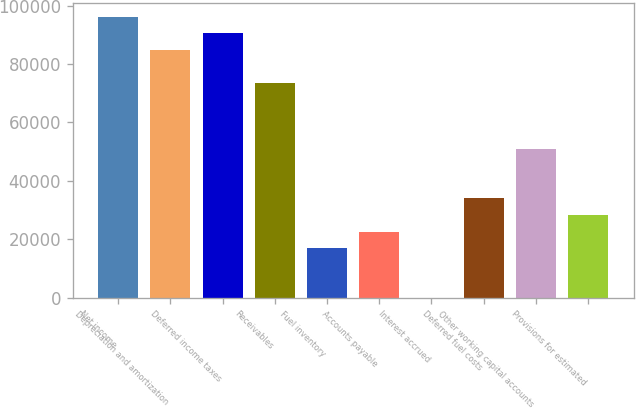Convert chart. <chart><loc_0><loc_0><loc_500><loc_500><bar_chart><fcel>Net income<fcel>Depreciation and amortization<fcel>Deferred income taxes<fcel>Receivables<fcel>Fuel inventory<fcel>Accounts payable<fcel>Interest accrued<fcel>Deferred fuel costs<fcel>Other working capital accounts<fcel>Provisions for estimated<nl><fcel>96211.6<fcel>84894<fcel>90552.8<fcel>73576.4<fcel>16988.4<fcel>22647.2<fcel>12<fcel>33964.8<fcel>50941.2<fcel>28306<nl></chart> 